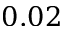Convert formula to latex. <formula><loc_0><loc_0><loc_500><loc_500>0 . 0 2</formula> 